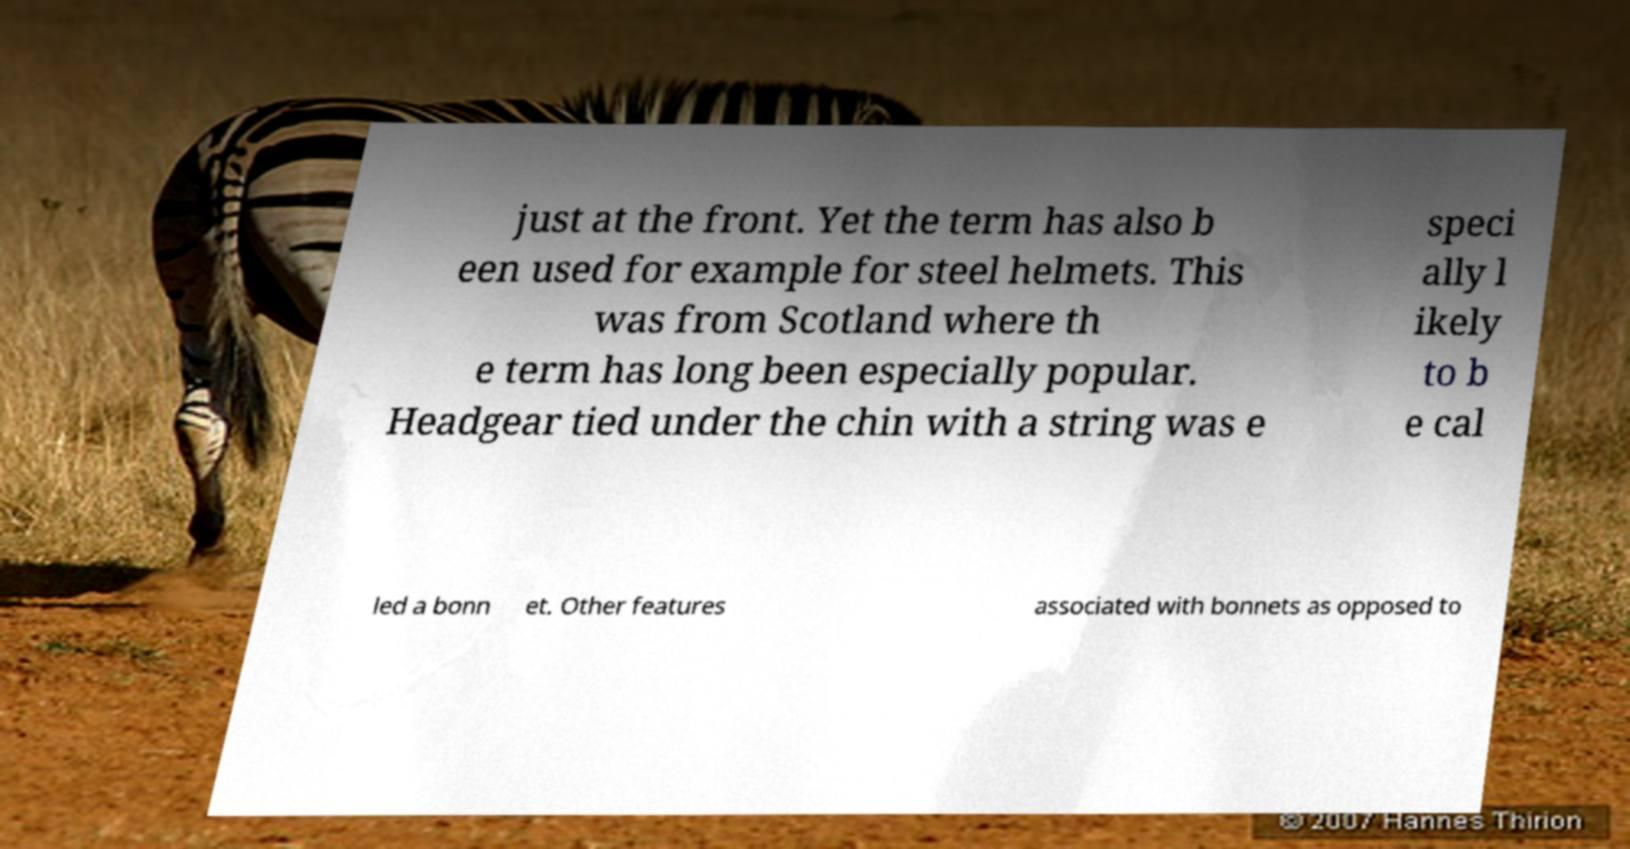Can you accurately transcribe the text from the provided image for me? just at the front. Yet the term has also b een used for example for steel helmets. This was from Scotland where th e term has long been especially popular. Headgear tied under the chin with a string was e speci ally l ikely to b e cal led a bonn et. Other features associated with bonnets as opposed to 